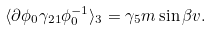<formula> <loc_0><loc_0><loc_500><loc_500>\langle \partial \phi _ { 0 } \gamma _ { 2 1 } \phi _ { 0 } ^ { - 1 } \rangle _ { 3 } = \gamma _ { 5 } m \sin { \beta } v .</formula> 